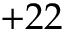Convert formula to latex. <formula><loc_0><loc_0><loc_500><loc_500>+ 2 2</formula> 